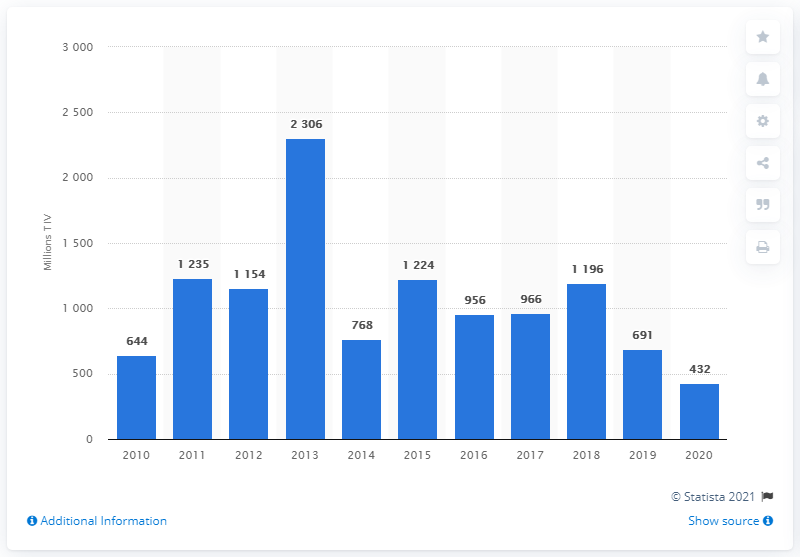How does the data from 2020 compare to the rest of the decade? The data from 2020 shows a significant reduction in the UAE's arms imports compared to the peak in 2014. While the value exceeded 2 billion USD in 2014, by 2020 it had decreased to 432 million USD, indicating the lowest import value of the decade and a substantial deviation from the decade's average. 